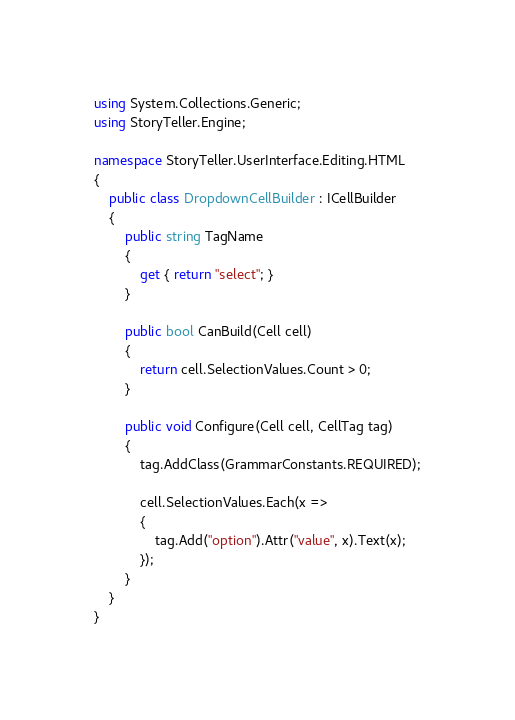Convert code to text. <code><loc_0><loc_0><loc_500><loc_500><_C#_>using System.Collections.Generic;
using StoryTeller.Engine;

namespace StoryTeller.UserInterface.Editing.HTML
{
    public class DropdownCellBuilder : ICellBuilder
    {
        public string TagName
        {
            get { return "select"; }
        }

        public bool CanBuild(Cell cell)
        {
            return cell.SelectionValues.Count > 0;
        }

        public void Configure(Cell cell, CellTag tag)
        {
            tag.AddClass(GrammarConstants.REQUIRED);

            cell.SelectionValues.Each(x =>
            {
                tag.Add("option").Attr("value", x).Text(x);
            });
        }
    }
}</code> 